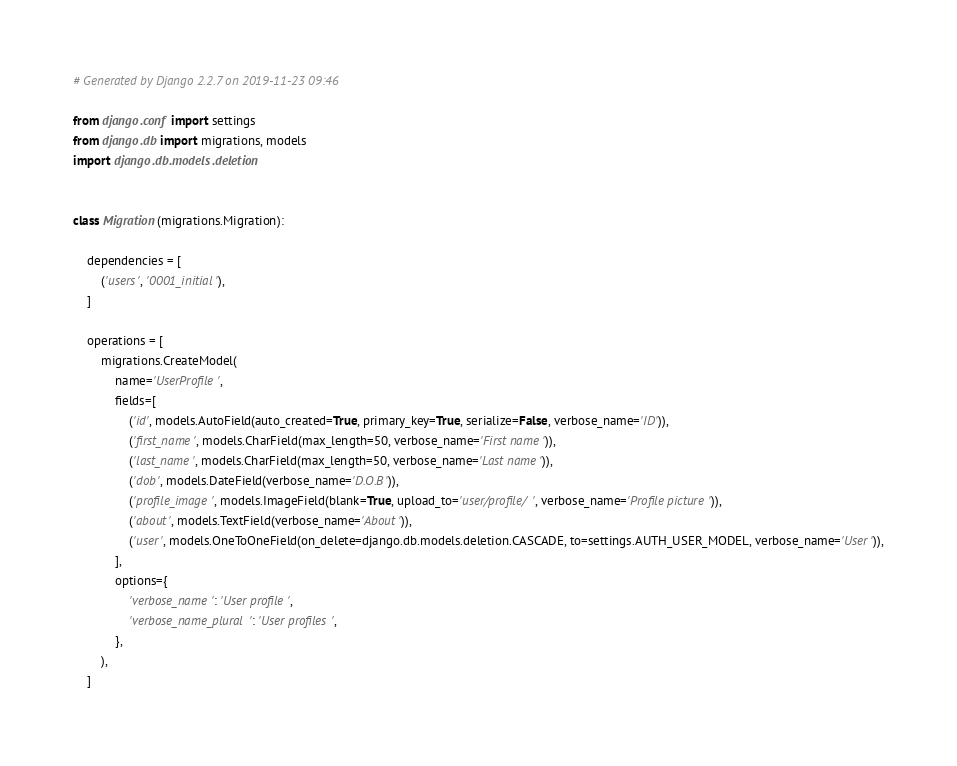Convert code to text. <code><loc_0><loc_0><loc_500><loc_500><_Python_># Generated by Django 2.2.7 on 2019-11-23 09:46

from django.conf import settings
from django.db import migrations, models
import django.db.models.deletion


class Migration(migrations.Migration):

    dependencies = [
        ('users', '0001_initial'),
    ]

    operations = [
        migrations.CreateModel(
            name='UserProfile',
            fields=[
                ('id', models.AutoField(auto_created=True, primary_key=True, serialize=False, verbose_name='ID')),
                ('first_name', models.CharField(max_length=50, verbose_name='First name')),
                ('last_name', models.CharField(max_length=50, verbose_name='Last name')),
                ('dob', models.DateField(verbose_name='D.O.B')),
                ('profile_image', models.ImageField(blank=True, upload_to='user/profile/', verbose_name='Profile picture')),
                ('about', models.TextField(verbose_name='About')),
                ('user', models.OneToOneField(on_delete=django.db.models.deletion.CASCADE, to=settings.AUTH_USER_MODEL, verbose_name='User')),
            ],
            options={
                'verbose_name': 'User profile',
                'verbose_name_plural': 'User profiles',
            },
        ),
    ]
</code> 